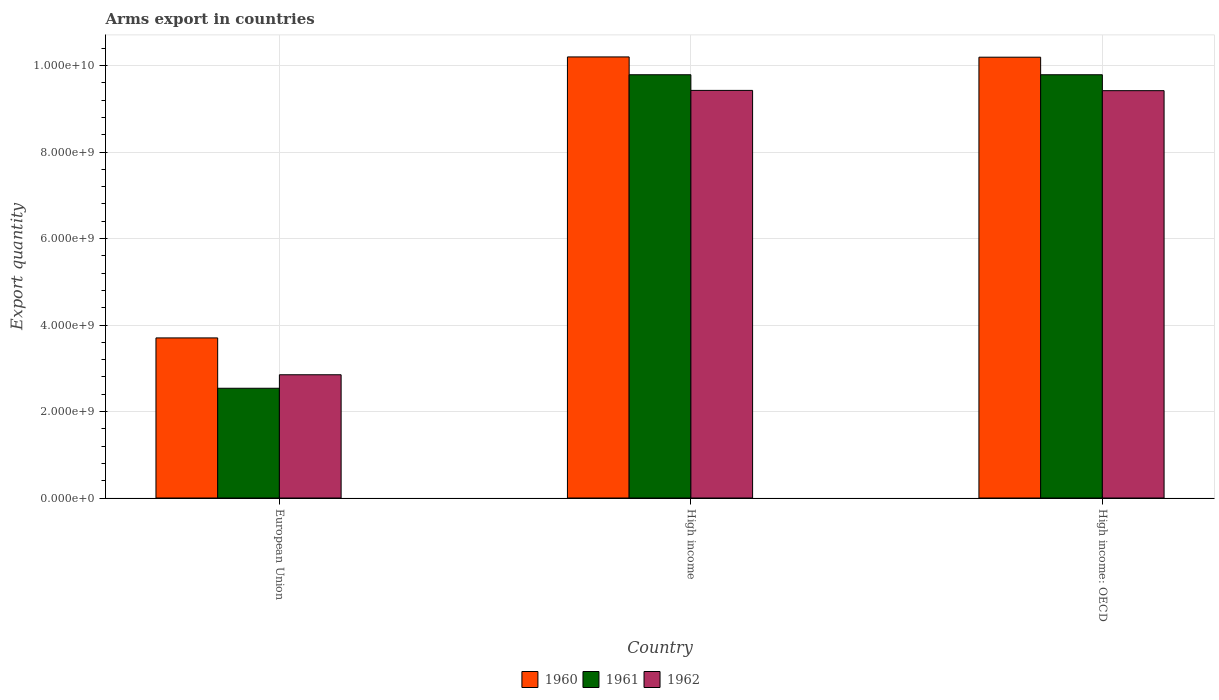How many different coloured bars are there?
Give a very brief answer. 3. How many groups of bars are there?
Offer a terse response. 3. Are the number of bars per tick equal to the number of legend labels?
Offer a terse response. Yes. Are the number of bars on each tick of the X-axis equal?
Your answer should be very brief. Yes. How many bars are there on the 1st tick from the left?
Your answer should be compact. 3. What is the total arms export in 1962 in High income: OECD?
Offer a terse response. 9.42e+09. Across all countries, what is the maximum total arms export in 1962?
Provide a succinct answer. 9.43e+09. Across all countries, what is the minimum total arms export in 1960?
Your answer should be very brief. 3.70e+09. In which country was the total arms export in 1962 maximum?
Your answer should be compact. High income. In which country was the total arms export in 1960 minimum?
Provide a succinct answer. European Union. What is the total total arms export in 1960 in the graph?
Offer a terse response. 2.41e+1. What is the difference between the total arms export in 1961 in European Union and that in High income: OECD?
Provide a succinct answer. -7.25e+09. What is the difference between the total arms export in 1962 in European Union and the total arms export in 1960 in High income: OECD?
Make the answer very short. -7.34e+09. What is the average total arms export in 1961 per country?
Your response must be concise. 7.37e+09. What is the difference between the total arms export of/in 1961 and total arms export of/in 1962 in High income: OECD?
Your answer should be compact. 3.68e+08. In how many countries, is the total arms export in 1962 greater than 800000000?
Offer a terse response. 3. What is the ratio of the total arms export in 1960 in High income to that in High income: OECD?
Keep it short and to the point. 1. Is the total arms export in 1962 in High income less than that in High income: OECD?
Make the answer very short. No. What is the difference between the highest and the second highest total arms export in 1961?
Offer a very short reply. 7.25e+09. What is the difference between the highest and the lowest total arms export in 1961?
Your answer should be very brief. 7.25e+09. How many bars are there?
Offer a very short reply. 9. Are all the bars in the graph horizontal?
Give a very brief answer. No. How many countries are there in the graph?
Make the answer very short. 3. What is the difference between two consecutive major ticks on the Y-axis?
Offer a terse response. 2.00e+09. Does the graph contain any zero values?
Make the answer very short. No. Where does the legend appear in the graph?
Offer a very short reply. Bottom center. How many legend labels are there?
Your response must be concise. 3. How are the legend labels stacked?
Your answer should be very brief. Horizontal. What is the title of the graph?
Give a very brief answer. Arms export in countries. Does "1988" appear as one of the legend labels in the graph?
Make the answer very short. No. What is the label or title of the X-axis?
Offer a very short reply. Country. What is the label or title of the Y-axis?
Offer a terse response. Export quantity. What is the Export quantity in 1960 in European Union?
Make the answer very short. 3.70e+09. What is the Export quantity of 1961 in European Union?
Keep it short and to the point. 2.54e+09. What is the Export quantity in 1962 in European Union?
Give a very brief answer. 2.85e+09. What is the Export quantity of 1960 in High income?
Your response must be concise. 1.02e+1. What is the Export quantity in 1961 in High income?
Provide a short and direct response. 9.79e+09. What is the Export quantity of 1962 in High income?
Provide a succinct answer. 9.43e+09. What is the Export quantity in 1960 in High income: OECD?
Your response must be concise. 1.02e+1. What is the Export quantity of 1961 in High income: OECD?
Provide a short and direct response. 9.79e+09. What is the Export quantity in 1962 in High income: OECD?
Your response must be concise. 9.42e+09. Across all countries, what is the maximum Export quantity of 1960?
Provide a succinct answer. 1.02e+1. Across all countries, what is the maximum Export quantity in 1961?
Provide a short and direct response. 9.79e+09. Across all countries, what is the maximum Export quantity of 1962?
Provide a succinct answer. 9.43e+09. Across all countries, what is the minimum Export quantity in 1960?
Keep it short and to the point. 3.70e+09. Across all countries, what is the minimum Export quantity of 1961?
Your answer should be very brief. 2.54e+09. Across all countries, what is the minimum Export quantity in 1962?
Your answer should be compact. 2.85e+09. What is the total Export quantity in 1960 in the graph?
Ensure brevity in your answer.  2.41e+1. What is the total Export quantity of 1961 in the graph?
Give a very brief answer. 2.21e+1. What is the total Export quantity in 1962 in the graph?
Provide a short and direct response. 2.17e+1. What is the difference between the Export quantity in 1960 in European Union and that in High income?
Provide a succinct answer. -6.50e+09. What is the difference between the Export quantity of 1961 in European Union and that in High income?
Offer a very short reply. -7.25e+09. What is the difference between the Export quantity in 1962 in European Union and that in High income?
Your answer should be compact. -6.58e+09. What is the difference between the Export quantity of 1960 in European Union and that in High income: OECD?
Your response must be concise. -6.49e+09. What is the difference between the Export quantity of 1961 in European Union and that in High income: OECD?
Your response must be concise. -7.25e+09. What is the difference between the Export quantity of 1962 in European Union and that in High income: OECD?
Offer a very short reply. -6.57e+09. What is the difference between the Export quantity of 1962 in High income and that in High income: OECD?
Offer a terse response. 6.00e+06. What is the difference between the Export quantity of 1960 in European Union and the Export quantity of 1961 in High income?
Offer a very short reply. -6.09e+09. What is the difference between the Export quantity of 1960 in European Union and the Export quantity of 1962 in High income?
Keep it short and to the point. -5.72e+09. What is the difference between the Export quantity of 1961 in European Union and the Export quantity of 1962 in High income?
Give a very brief answer. -6.89e+09. What is the difference between the Export quantity of 1960 in European Union and the Export quantity of 1961 in High income: OECD?
Provide a succinct answer. -6.09e+09. What is the difference between the Export quantity of 1960 in European Union and the Export quantity of 1962 in High income: OECD?
Make the answer very short. -5.72e+09. What is the difference between the Export quantity of 1961 in European Union and the Export quantity of 1962 in High income: OECD?
Ensure brevity in your answer.  -6.88e+09. What is the difference between the Export quantity of 1960 in High income and the Export quantity of 1961 in High income: OECD?
Provide a short and direct response. 4.12e+08. What is the difference between the Export quantity in 1960 in High income and the Export quantity in 1962 in High income: OECD?
Provide a short and direct response. 7.80e+08. What is the difference between the Export quantity in 1961 in High income and the Export quantity in 1962 in High income: OECD?
Your response must be concise. 3.68e+08. What is the average Export quantity of 1960 per country?
Ensure brevity in your answer.  8.03e+09. What is the average Export quantity of 1961 per country?
Your answer should be compact. 7.37e+09. What is the average Export quantity in 1962 per country?
Keep it short and to the point. 7.23e+09. What is the difference between the Export quantity in 1960 and Export quantity in 1961 in European Union?
Provide a short and direct response. 1.16e+09. What is the difference between the Export quantity in 1960 and Export quantity in 1962 in European Union?
Provide a short and direct response. 8.52e+08. What is the difference between the Export quantity in 1961 and Export quantity in 1962 in European Union?
Make the answer very short. -3.12e+08. What is the difference between the Export quantity in 1960 and Export quantity in 1961 in High income?
Offer a very short reply. 4.12e+08. What is the difference between the Export quantity of 1960 and Export quantity of 1962 in High income?
Give a very brief answer. 7.74e+08. What is the difference between the Export quantity of 1961 and Export quantity of 1962 in High income?
Make the answer very short. 3.62e+08. What is the difference between the Export quantity of 1960 and Export quantity of 1961 in High income: OECD?
Offer a terse response. 4.06e+08. What is the difference between the Export quantity in 1960 and Export quantity in 1962 in High income: OECD?
Provide a succinct answer. 7.74e+08. What is the difference between the Export quantity of 1961 and Export quantity of 1962 in High income: OECD?
Provide a succinct answer. 3.68e+08. What is the ratio of the Export quantity in 1960 in European Union to that in High income?
Offer a very short reply. 0.36. What is the ratio of the Export quantity of 1961 in European Union to that in High income?
Provide a succinct answer. 0.26. What is the ratio of the Export quantity of 1962 in European Union to that in High income?
Your response must be concise. 0.3. What is the ratio of the Export quantity in 1960 in European Union to that in High income: OECD?
Provide a short and direct response. 0.36. What is the ratio of the Export quantity of 1961 in European Union to that in High income: OECD?
Give a very brief answer. 0.26. What is the ratio of the Export quantity in 1962 in European Union to that in High income: OECD?
Your response must be concise. 0.3. What is the difference between the highest and the second highest Export quantity of 1961?
Provide a succinct answer. 0. What is the difference between the highest and the lowest Export quantity in 1960?
Keep it short and to the point. 6.50e+09. What is the difference between the highest and the lowest Export quantity of 1961?
Your response must be concise. 7.25e+09. What is the difference between the highest and the lowest Export quantity of 1962?
Give a very brief answer. 6.58e+09. 